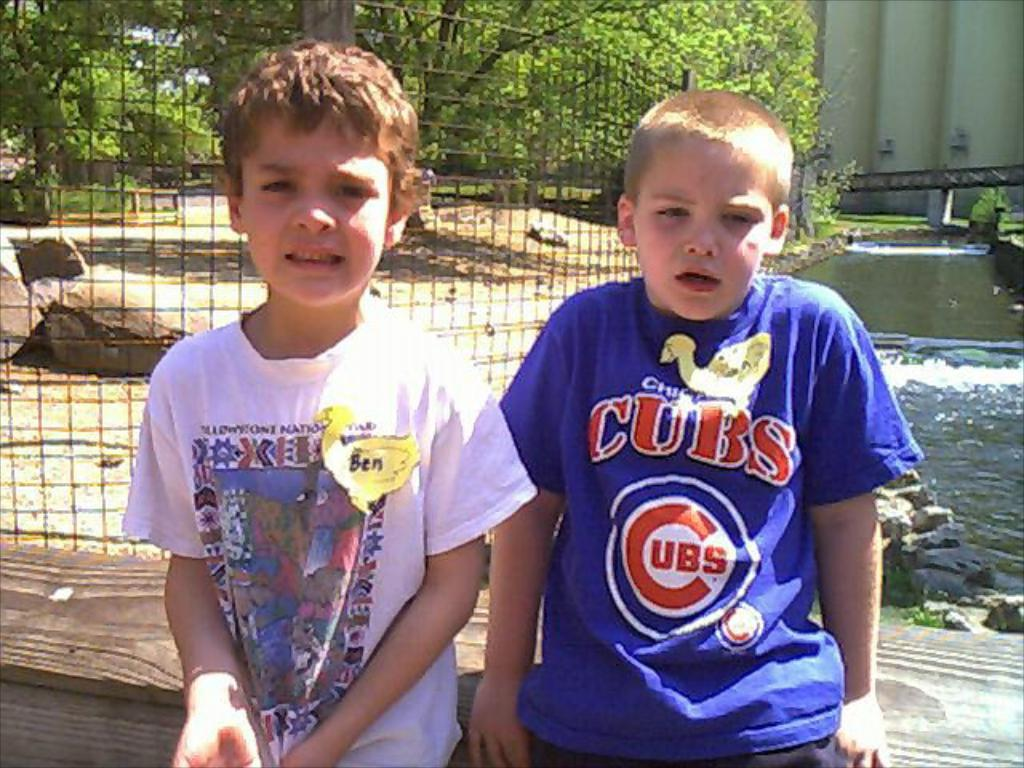<image>
Summarize the visual content of the image. 2 kids getting picture taken outside, one of the kids is named Ben, and the other has a Chicago Cubs shirt on. 